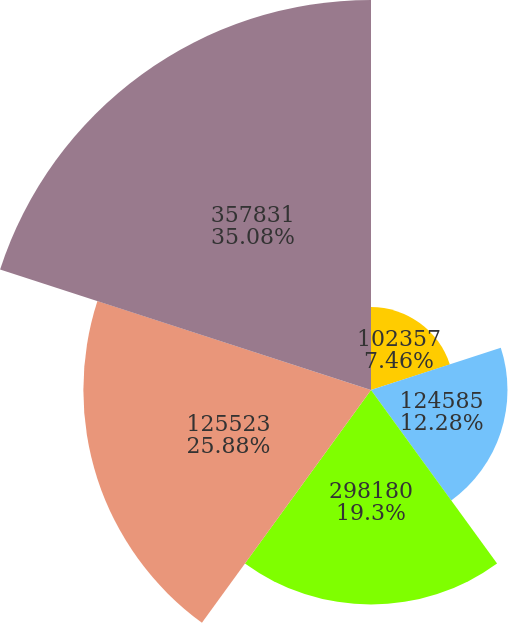Convert chart. <chart><loc_0><loc_0><loc_500><loc_500><pie_chart><fcel>102357<fcel>124585<fcel>298180<fcel>125523<fcel>357831<nl><fcel>7.46%<fcel>12.28%<fcel>19.3%<fcel>25.88%<fcel>35.09%<nl></chart> 